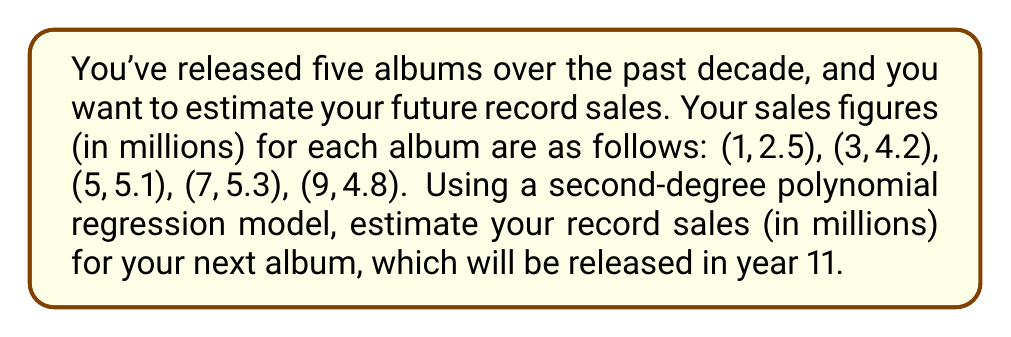Solve this math problem. 1. We need to fit a second-degree polynomial of the form $y = ax^2 + bx + c$ to the given data points.

2. To find the coefficients $a$, $b$, and $c$, we'll use a polynomial regression calculator or software. After inputting the data points, we get:

   $y = -0.0562x^2 + 0.8361x + 1.7857$

3. Now that we have our polynomial function, we can estimate the sales for year 11 by substituting $x = 11$ into the equation:

   $y = -0.0562(11)^2 + 0.8361(11) + 1.7857$

4. Let's calculate step by step:
   $y = -0.0562(121) + 0.8361(11) + 1.7857$
   $y = -6.8002 + 9.1971 + 1.7857$
   $y = 4.1826$

5. Rounding to one decimal place (as the original data was given):
   $y ≈ 4.2$
Answer: 4.2 million 